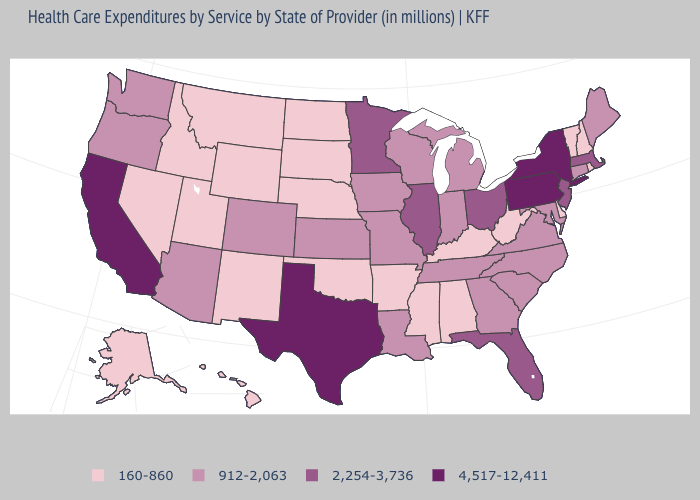Among the states that border Utah , which have the lowest value?
Concise answer only. Idaho, Nevada, New Mexico, Wyoming. Does the map have missing data?
Be succinct. No. Which states have the lowest value in the USA?
Keep it brief. Alabama, Alaska, Arkansas, Delaware, Hawaii, Idaho, Kentucky, Mississippi, Montana, Nebraska, Nevada, New Hampshire, New Mexico, North Dakota, Oklahoma, Rhode Island, South Dakota, Utah, Vermont, West Virginia, Wyoming. What is the value of West Virginia?
Give a very brief answer. 160-860. What is the highest value in states that border Massachusetts?
Short answer required. 4,517-12,411. Among the states that border Ohio , which have the highest value?
Concise answer only. Pennsylvania. What is the lowest value in the South?
Quick response, please. 160-860. Name the states that have a value in the range 4,517-12,411?
Write a very short answer. California, New York, Pennsylvania, Texas. What is the value of Massachusetts?
Write a very short answer. 2,254-3,736. Name the states that have a value in the range 160-860?
Keep it brief. Alabama, Alaska, Arkansas, Delaware, Hawaii, Idaho, Kentucky, Mississippi, Montana, Nebraska, Nevada, New Hampshire, New Mexico, North Dakota, Oklahoma, Rhode Island, South Dakota, Utah, Vermont, West Virginia, Wyoming. Name the states that have a value in the range 160-860?
Short answer required. Alabama, Alaska, Arkansas, Delaware, Hawaii, Idaho, Kentucky, Mississippi, Montana, Nebraska, Nevada, New Hampshire, New Mexico, North Dakota, Oklahoma, Rhode Island, South Dakota, Utah, Vermont, West Virginia, Wyoming. Name the states that have a value in the range 2,254-3,736?
Concise answer only. Florida, Illinois, Massachusetts, Minnesota, New Jersey, Ohio. Does Mississippi have the lowest value in the USA?
Short answer required. Yes. Name the states that have a value in the range 2,254-3,736?
Concise answer only. Florida, Illinois, Massachusetts, Minnesota, New Jersey, Ohio. 